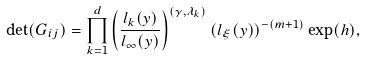Convert formula to latex. <formula><loc_0><loc_0><loc_500><loc_500>\det ( G _ { i j } ) = \prod _ { k = 1 } ^ { d } \left ( \frac { l _ { k } ( y ) } { l _ { \infty } ( y ) } \right ) ^ { ( \gamma , \lambda _ { k } ) } ( l _ { \xi } ( y ) ) ^ { - ( m + 1 ) } \exp ( h ) ,</formula> 